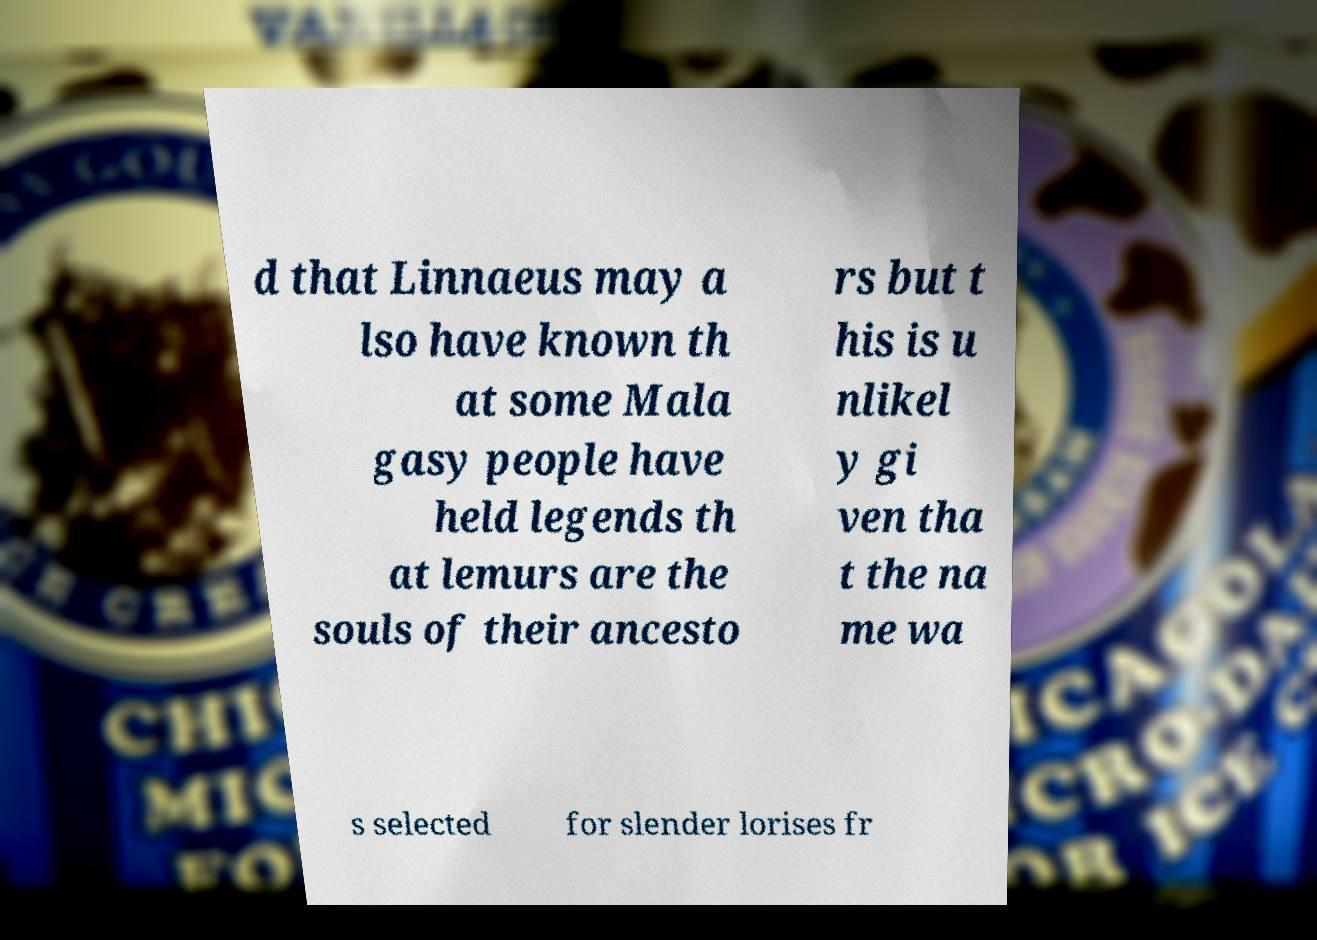For documentation purposes, I need the text within this image transcribed. Could you provide that? d that Linnaeus may a lso have known th at some Mala gasy people have held legends th at lemurs are the souls of their ancesto rs but t his is u nlikel y gi ven tha t the na me wa s selected for slender lorises fr 